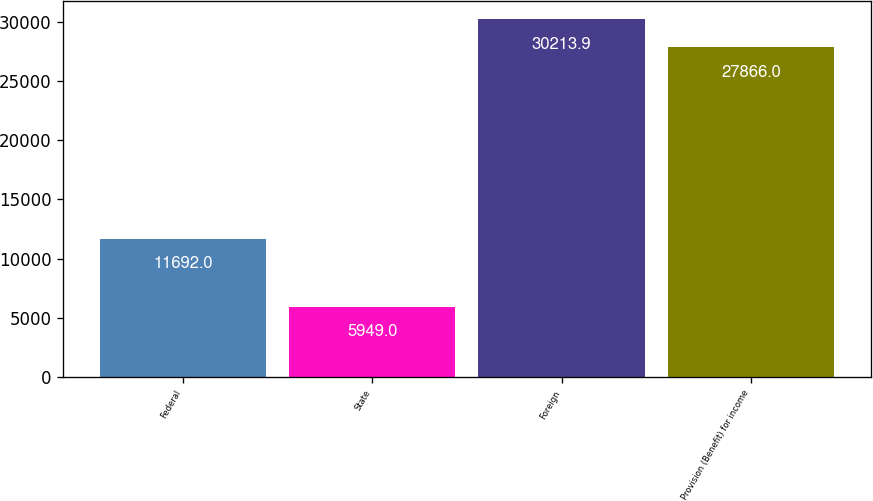Convert chart. <chart><loc_0><loc_0><loc_500><loc_500><bar_chart><fcel>Federal<fcel>State<fcel>Foreign<fcel>Provision (Benefit) for income<nl><fcel>11692<fcel>5949<fcel>30213.9<fcel>27866<nl></chart> 